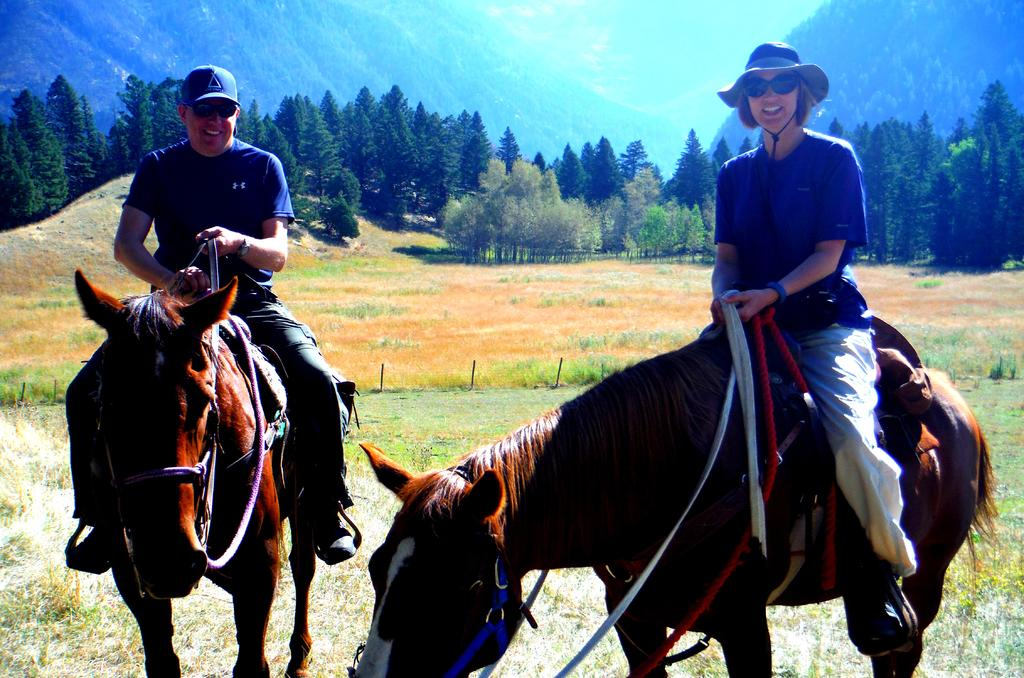How many people are in the image? There are two persons in the image. What are the persons doing in the image? The persons are sitting on horses. What can be seen in the background of the image? There are trees, grass, mountains, and the sky visible in the background of the image. What is the thought process of the zebra in the image? There is no zebra present in the image, so it is not possible to determine its thought process. 